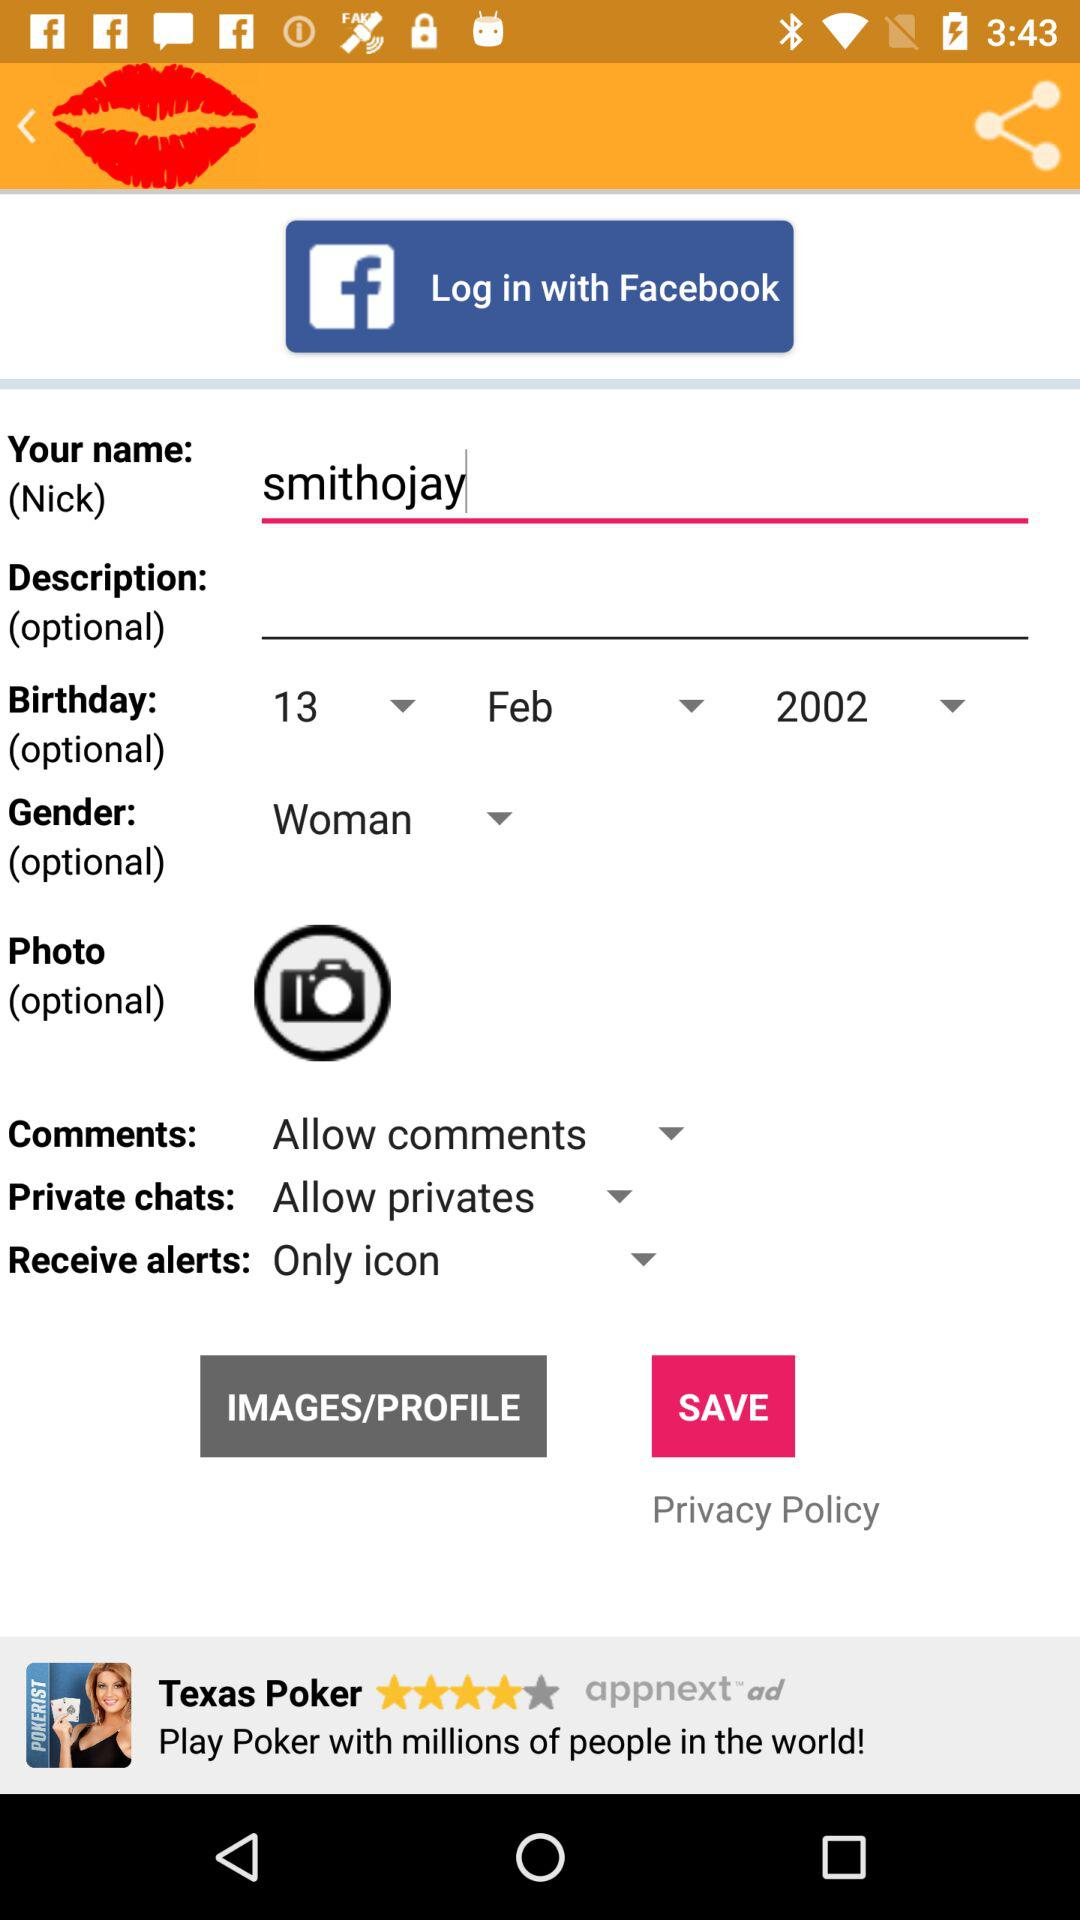Through what application can we log in? You can log in through "Facebook". 